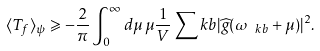<formula> <loc_0><loc_0><loc_500><loc_500>\langle T _ { f } \rangle _ { \psi } \geqslant - \frac { 2 } { \pi } \int _ { 0 } ^ { \infty } d \mu \, \mu \frac { 1 } { V } \sum _ { \ } k b | \widehat { g } ( \omega _ { \ k b } + \mu ) | ^ { 2 } .</formula> 